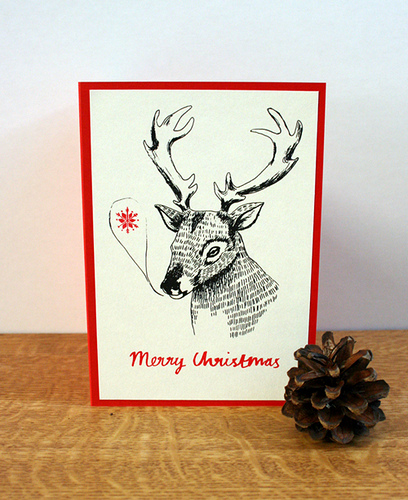<image>
Can you confirm if the pinecone is in the picture? No. The pinecone is not contained within the picture. These objects have a different spatial relationship. Is the pinecone in front of the deer? Yes. The pinecone is positioned in front of the deer, appearing closer to the camera viewpoint. 